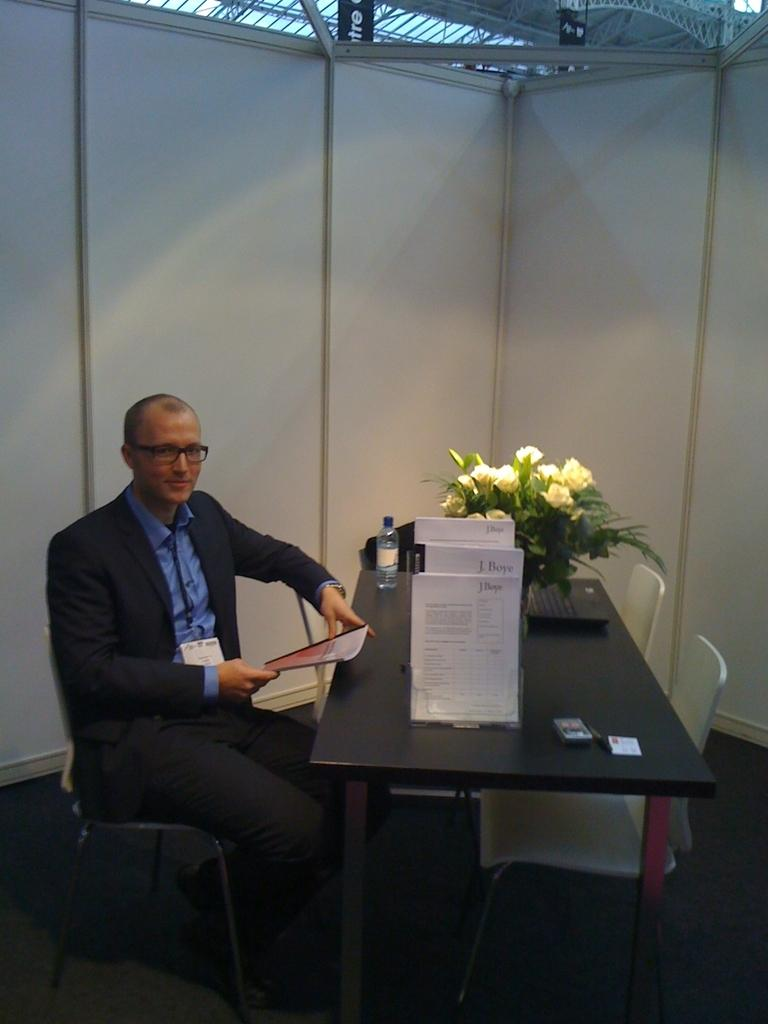What is the main piece of furniture in the image? There is a table in the image. What items can be seen on the table? There are papers, flowers, a bottle, and a laptop on the table. Is there any other object on the table? Yes, there is a person sitting on the left side of the table. What is the person wearing? The person is wearing a suit. How many frogs are sitting on the table in the image? There are no frogs present in the image; the table only contains papers, flowers, a bottle, a laptop, and a person sitting on the left side. 